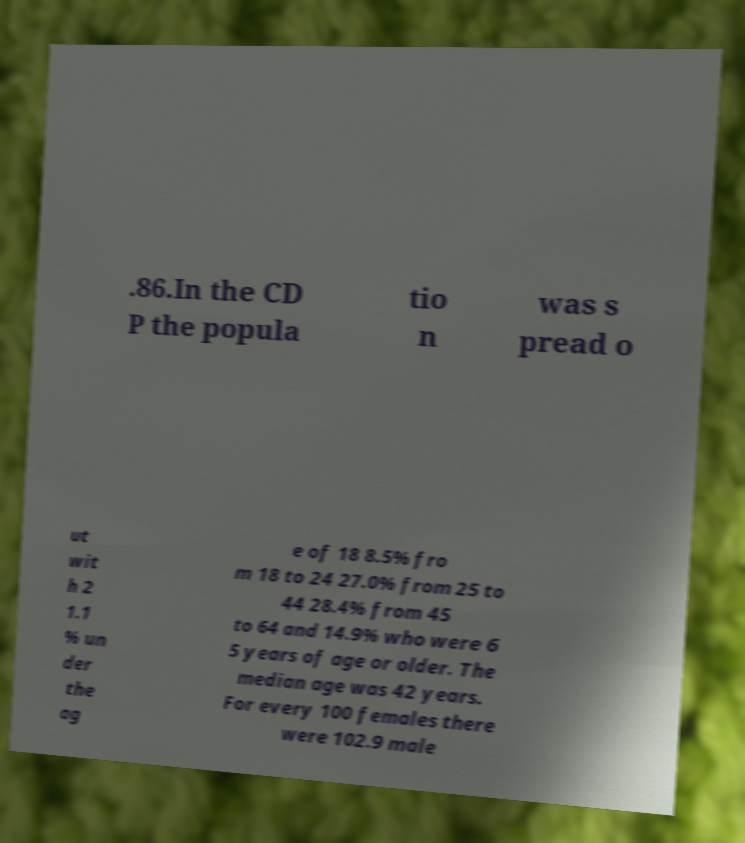What messages or text are displayed in this image? I need them in a readable, typed format. .86.In the CD P the popula tio n was s pread o ut wit h 2 1.1 % un der the ag e of 18 8.5% fro m 18 to 24 27.0% from 25 to 44 28.4% from 45 to 64 and 14.9% who were 6 5 years of age or older. The median age was 42 years. For every 100 females there were 102.9 male 